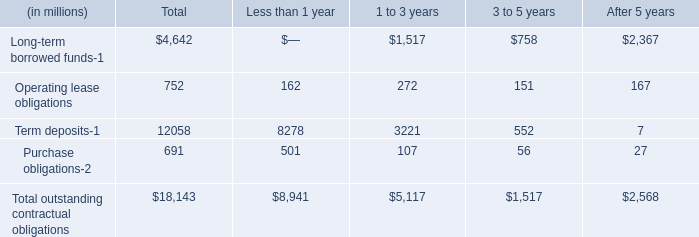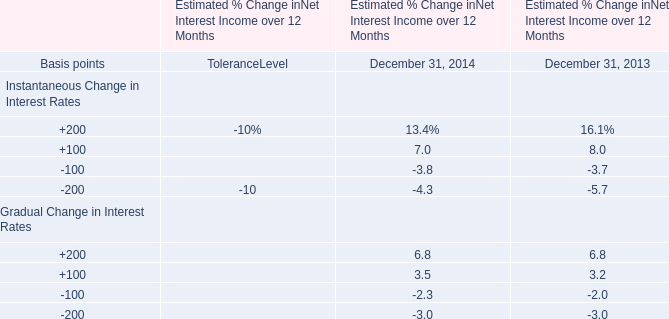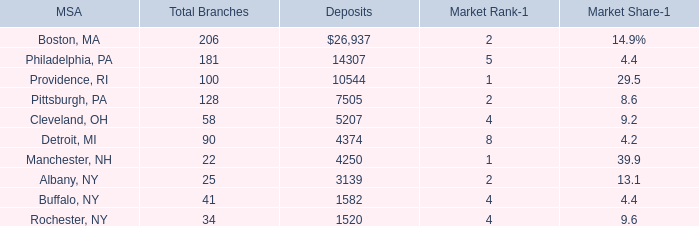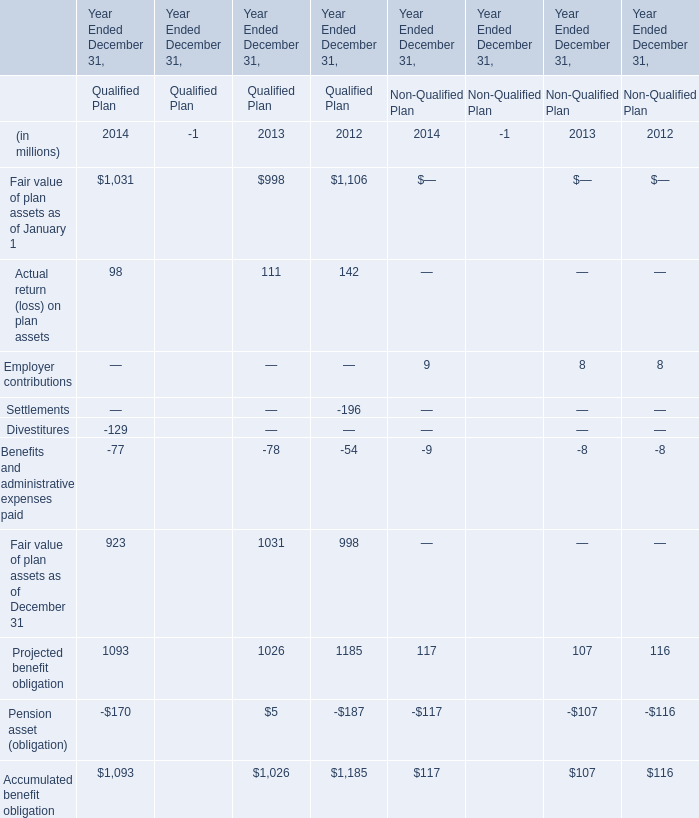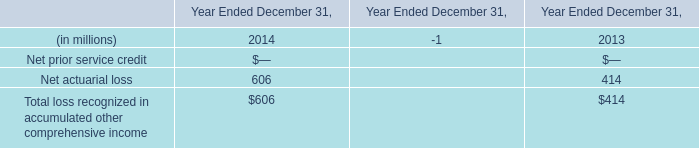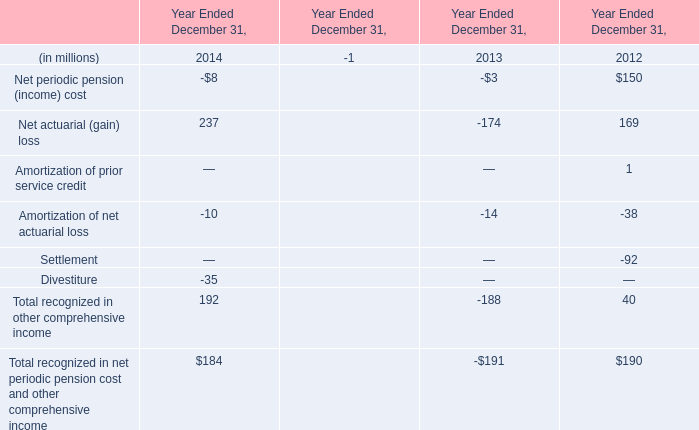what is the increase of Net actuarial (gain) loss? (in million) 
Computations: (237 - -174)
Answer: 411.0. 